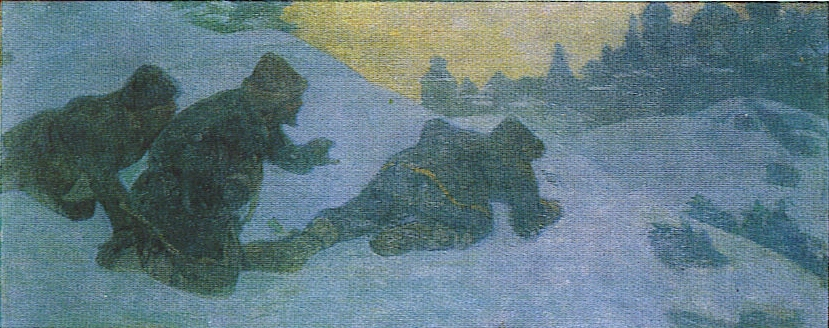Imagine these figures just encountered something unexpected. What might that be, and how would they react? Perhaps these figures have just come upon a hidden cache of supplies left by a traveler or a long-abandoned shelter they didn't know existed. Their reaction would likely be one of cautious optimism. They would carefully approach the discovery, checking for safety or signs of threat. If the cache is safe, they would eagerly gather the supplies, grateful for the unexpected boon which might help them survive the harsh conditions. This discovery would lift their spirits, providing much-needed relief. How would the scene change if this were set at night under moonlight? If the scene were set at night under moonlight, the color palette would shift to darker shades of blue and grey, with bright highlights from the moonlight reflecting off the snow. The figures would become shadows, their movements more cautious and stealthy. The distant structures would be barely visible, creating an even more mysterious and eerie atmosphere. The cold would seem more intense, and the sense of isolation and vulnerability would be heightened, adding a layer of suspense and quiet tension to the scene. 